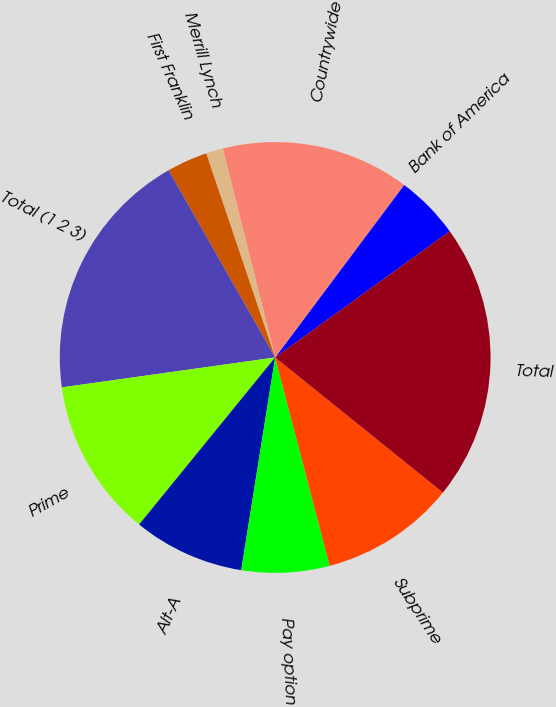Convert chart to OTSL. <chart><loc_0><loc_0><loc_500><loc_500><pie_chart><fcel>Bank of America<fcel>Countrywide<fcel>Merrill Lynch<fcel>First Franklin<fcel>Total (1 2 3)<fcel>Prime<fcel>Alt-A<fcel>Pay option<fcel>Subprime<fcel>Total<nl><fcel>4.82%<fcel>14.12%<fcel>1.28%<fcel>3.05%<fcel>18.98%<fcel>11.9%<fcel>8.36%<fcel>6.59%<fcel>10.13%<fcel>20.75%<nl></chart> 